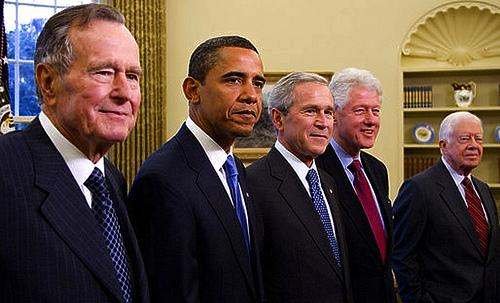Express in a creative way the context of the image. A quintet of extraordinary leaders, united by a common bond, stand proudly in a room adorned with a flag, paintings, and an intriguing shelf. Describe the ties worn by George H.W. Bush, Barack Obama, and George W. Bush. George H.W. Bush, Barack Obama, and George W. Bush are all wearing blue ties in the image. In a casual language style, mention what the president from Illinois is doing in the image. Barack Obama, the dude from Illinois, is just chilling with the other presidents, wearing a blue tie. Using a formal language style, describe the hair color of Bill Clinton and Jimmy Carter. Both President William Jefferson Clinton and President Jimmy Carter possess white hair. Describe the surroundings in the image. There is a flag in the corner of the room, a window behind George H.W. Bush, a shelf with books, vases, and plates, and a painting behind the men. Mention an interesting feature of the shelf in the image. The shelf is set into the wall and has blue and gold books, a brown and white pitcher, and a blue and white decorative plate. Give a brief summary of the people featured in the image. The image features five US Presidents - George H.W. Bush, Barack Obama, George W. Bush, Bill Clinton, and Jimmy Carter, standing in a row. What are the presidents wearing in the image? The presidents are wearing black suits and ties, with three of them wearing blue ties and two of them wearing red ties. Who are the two presidents wearing red ties? Bill Clinton and Jimmy Carter are wearing red ties in the image. What is the scene behind the five U.S. Presidents? Behind the five presidents, there is a window with gold drapes, an American flag, and a painting on the wall. 